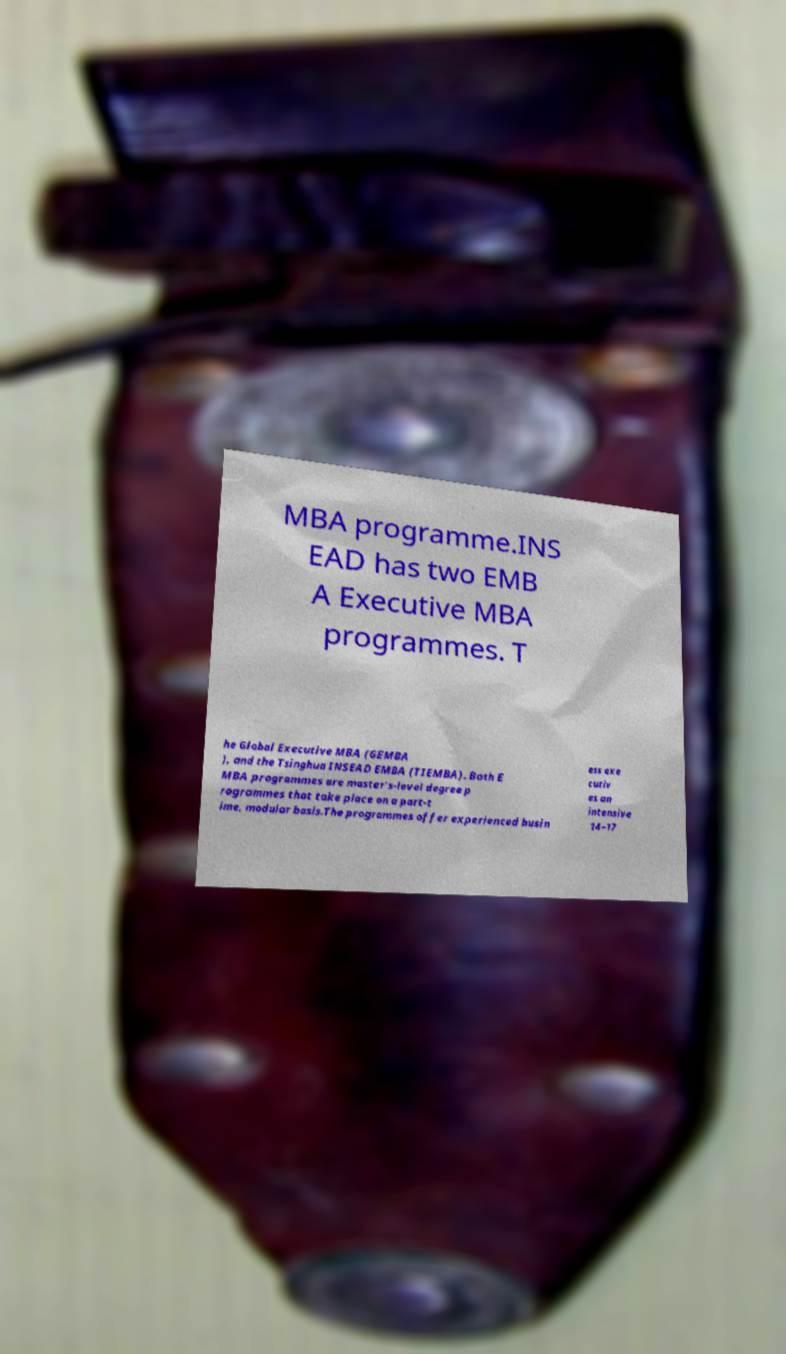Can you accurately transcribe the text from the provided image for me? MBA programme.INS EAD has two EMB A Executive MBA programmes. T he Global Executive MBA (GEMBA ), and the Tsinghua INSEAD EMBA (TIEMBA). Both E MBA programmes are master's-level degree p rogrammes that take place on a part-t ime, modular basis.The programmes offer experienced busin ess exe cutiv es an intensive 14–17 